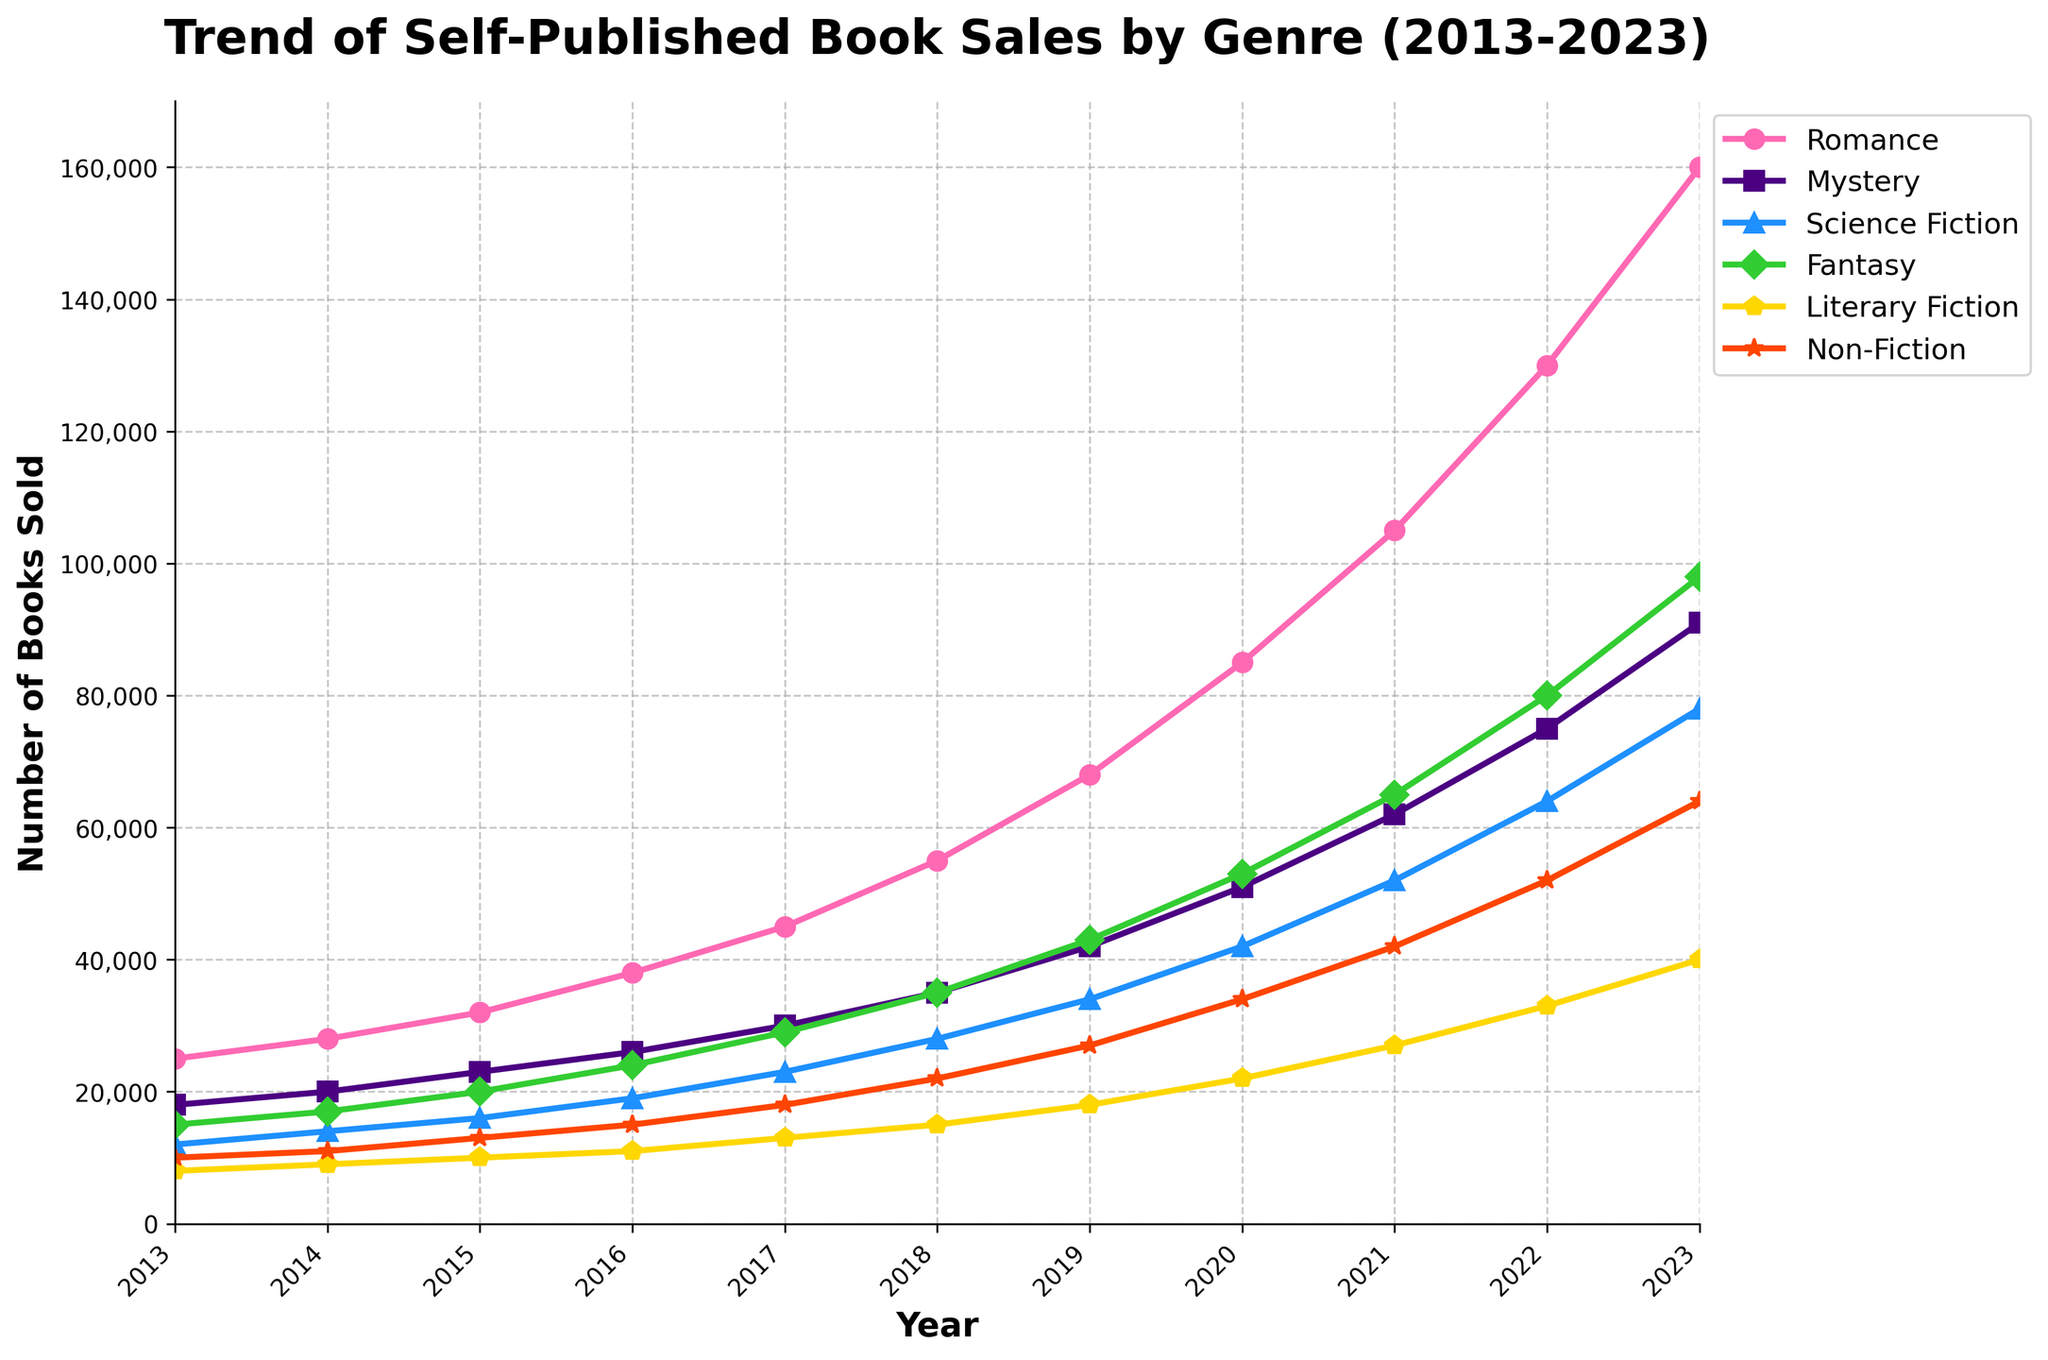Which genre has the highest growth in sales from 2013 to 2023? To determine the genre with the highest growth in sales from 2013 to 2023, subtract the sales figures of 2013 from those of 2023 for each genre. Romance grows from 25,000 to 160,000 (135,000 growth), Mystery from 18,000 to 91,000 (73,000 growth), Science Fiction from 12,000 to 78,000 (66,000 growth), Fantasy from 15,000 to 98,000 (83,000 growth), Literary Fiction from 8,000 to 40,000 (32,000 growth), Non-Fiction from 10,000 to 64,000 (54,000 growth). Romance has the highest growth with 135,000.
Answer: Romance Which genre had the smallest increase in sales from 2013 to 2023? To find the genre with the smallest increase, subtract the 2013 sales from the 2023 sales for each genre: Romance increases by 135,000, Mystery by 73,000, Science Fiction by 66,000, Fantasy by 83,000, Literary Fiction by 32,000, Non-Fiction by 54,000. Literary Fiction has the smallest increase at 32,000.
Answer: Literary Fiction In which year did Fantasy sales first surpass Science Fiction sales? Examine the sales figures year by year until Fantasy exceeds Science Fiction. In 2015, Science Fiction has 16,000 and Fantasy has 20,000. Therefore, 2015 is the year when Fantasy sales first surpassed Science Fiction sales.
Answer: 2015 By how much did sales of Non-Fiction increase from 2020 to 2023? Subtract Non-Fiction sales in 2020 from those in 2023: 64,000 - 34,000 = 30,000. Sales increased by 30,000 units from 2020 to 2023.
Answer: 30,000 Which genre showed a consistent increase in sales every year? Visually inspect each genre's trend line on the plot to see if there's a year-on-year increase every year without any drops. Romance, Mystery, Science Fiction, Fantasy, Literary Fiction, and Non-Fiction all show consistent increases.
Answer: All genres Which year had the highest overall sales across all genres combined? Add the sales figures of all genres for each year and compare: 2013 = 80,000, 2014 = 89,000, 2015 = 111,000, 2016 = 133,000, 2017 = 158,000, 2018 = 190,000, 2019 = 237,000, 2020 = 289,000, 2021 = 353,000, 2022 = 414,000, 2023 = 541,000. The year 2023 has the highest combined sales of 541,000.
Answer: 2023 What was the combined sales figure for Mystery and Literary Fiction in 2017? Sum the sales of Mystery and Literary Fiction in 2017: 30,000 (Mystery) + 13,000 (Literary Fiction) = 43,000.
Answer: 43,000 What percentage increase in sales did Romance experience from 2021 to 2023? Compute the percentage increase: (Sales in 2023 - Sales in 2021) / Sales in 2021 * 100%. For Romance: (160,000 - 105,000) / 105,000 * 100% ≈ 52.38%.
Answer: 52.38% In what year did Non-Fiction sales first exceed 20,000? Look at the Non-Fiction trend line where it surpasses 20,000. This first occurs in 2018 with sales of 22,000.
Answer: 2018 